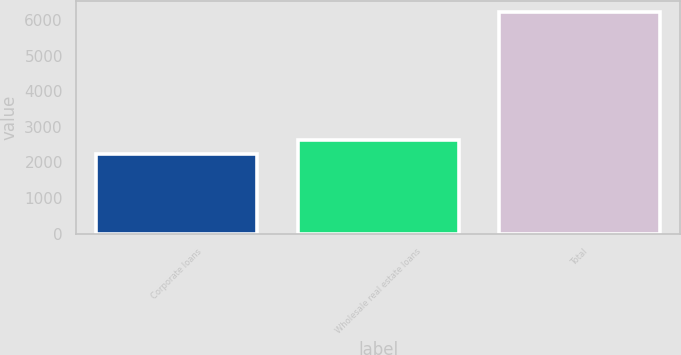Convert chart. <chart><loc_0><loc_0><loc_500><loc_500><bar_chart><fcel>Corporate loans<fcel>Wholesale real estate loans<fcel>Total<nl><fcel>2229<fcel>2628.1<fcel>6220<nl></chart> 